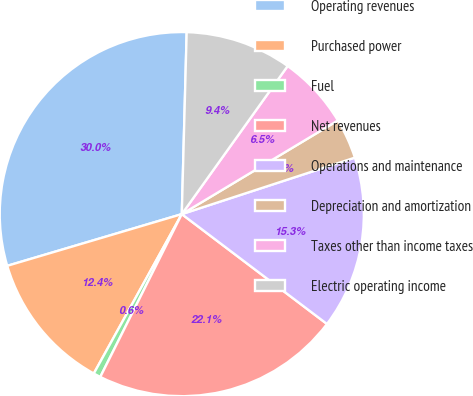Convert chart. <chart><loc_0><loc_0><loc_500><loc_500><pie_chart><fcel>Operating revenues<fcel>Purchased power<fcel>Fuel<fcel>Net revenues<fcel>Operations and maintenance<fcel>Depreciation and amortization<fcel>Taxes other than income taxes<fcel>Electric operating income<nl><fcel>30.01%<fcel>12.39%<fcel>0.64%<fcel>22.08%<fcel>15.33%<fcel>3.58%<fcel>6.52%<fcel>9.45%<nl></chart> 